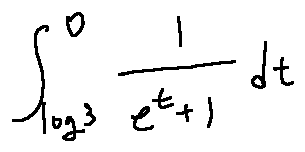<formula> <loc_0><loc_0><loc_500><loc_500>\int \lim i t s _ { \log 3 } ^ { 0 } \frac { 1 } { e ^ { t } + 1 } d t</formula> 